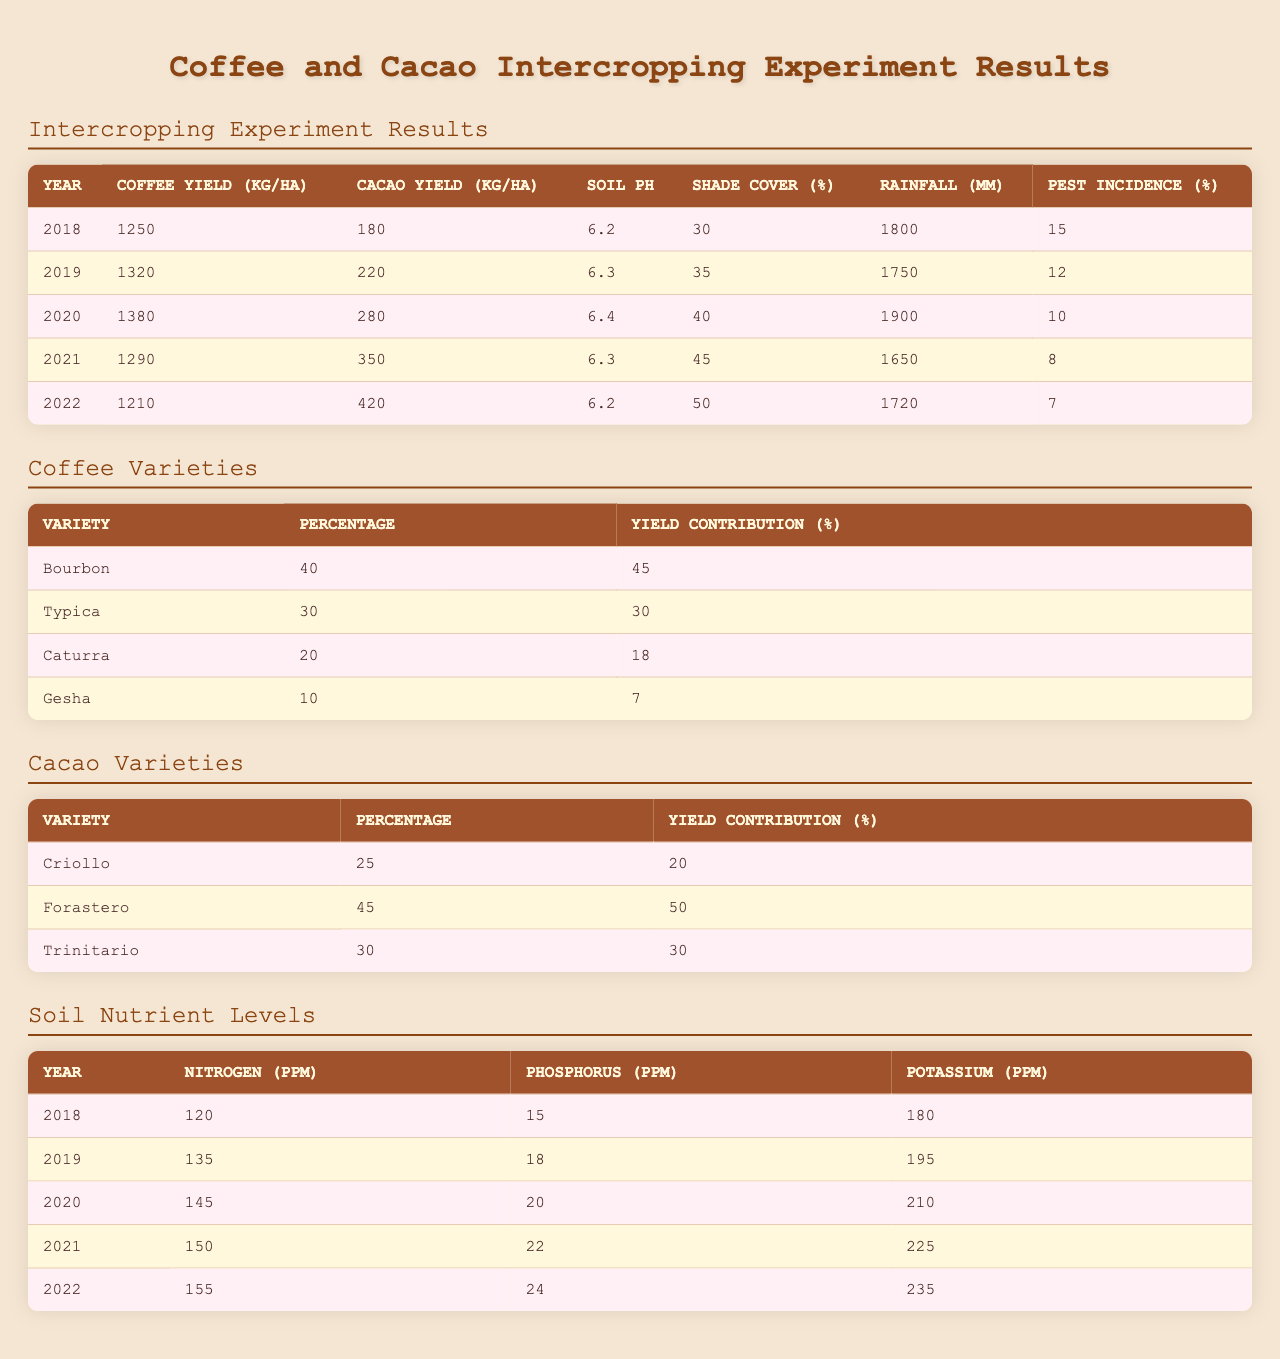What is the coffee yield in 2020? The table shows the coffee yield for each year, and for the year 2020, the coffee yield is listed as 1380 kg/ha.
Answer: 1380 kg/ha What was the cacao yield in 2019? Referring to the table, the cacao yield for the year 2019 is stated as 220 kg/ha.
Answer: 220 kg/ha What is the average cacao yield over the 5 years? We sum the cacao yields for all five years (180 + 220 + 280 + 350 + 420 = 1450), then divide by the number of years (5), which gives us 1450 / 5 = 290 kg/ha.
Answer: 290 kg/ha Is the pest incidence lower in 2022 than in 2018? In the table, the pest incidence for 2018 is 15% and for 2022 it is 7%. Since 7% is less than 15%, the statement is true.
Answer: Yes In which year was the soil pH the highest? The soil pH for each year is listed, and the highest pH is 6.4, which is recorded in the year 2020.
Answer: 2020 What is the difference in coffee yield between 2018 and 2021? The coffee yield in 2018 is 1250 kg/ha and in 2021 is 1290 kg/ha. To find the difference, we subtract 1250 from 1290, resulting in 40 kg/ha.
Answer: 40 kg/ha What year had the highest rainfall? By examining the rainfall data, 2018 had 1800 mm and 2020 had 1900 mm. Comparing these values, 2020 has the highest rainfall at 1900 mm.
Answer: 2020 Which coffee variety contributes the most to the yield? Looking at the coffee varieties table, Bourbon contributes 45% to the yield, which is the highest compared to other varieties.
Answer: Bourbon Is the nitrogen level consistent from year to year? The nitrogen levels increase from 120 ppm in 2018 to 155 ppm in 2022, indicating there is no consistency.
Answer: No What is the total coffee yield across all five years? To find the total, we add all coffee yields together: 1250 + 1320 + 1380 + 1290 + 1210 = 6650 kg/ha.
Answer: 6650 kg/ha In which year was the shade cover percentage 50%? The table lists the shade cover percentage for each year, and it shows that the shade cover reached 50% in 2022.
Answer: 2022 What is the average soil pH over the five years? The soil pH values are 6.2, 6.3, 6.4, 6.3, and 6.2. Summing these (6.2 + 6.3 + 6.4 + 6.3 + 6.2 = 31.6) and dividing by 5 results in an average of 6.32.
Answer: 6.32 